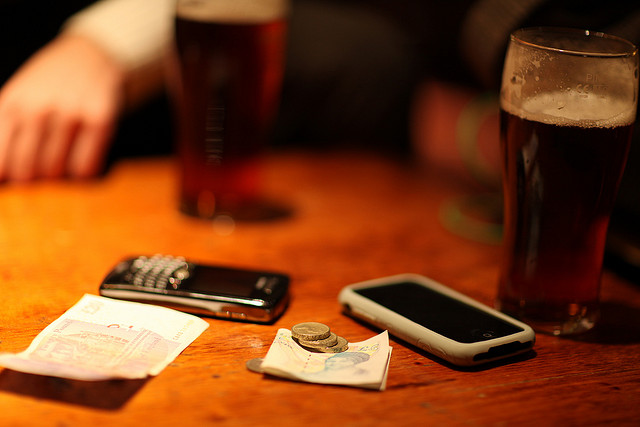<image>What body part can be seen in the background? There is no body part in the background. However, it is generally seen as a hand. What body part can be seen in the background? I would say the body part that can be seen in the background is the hand. 